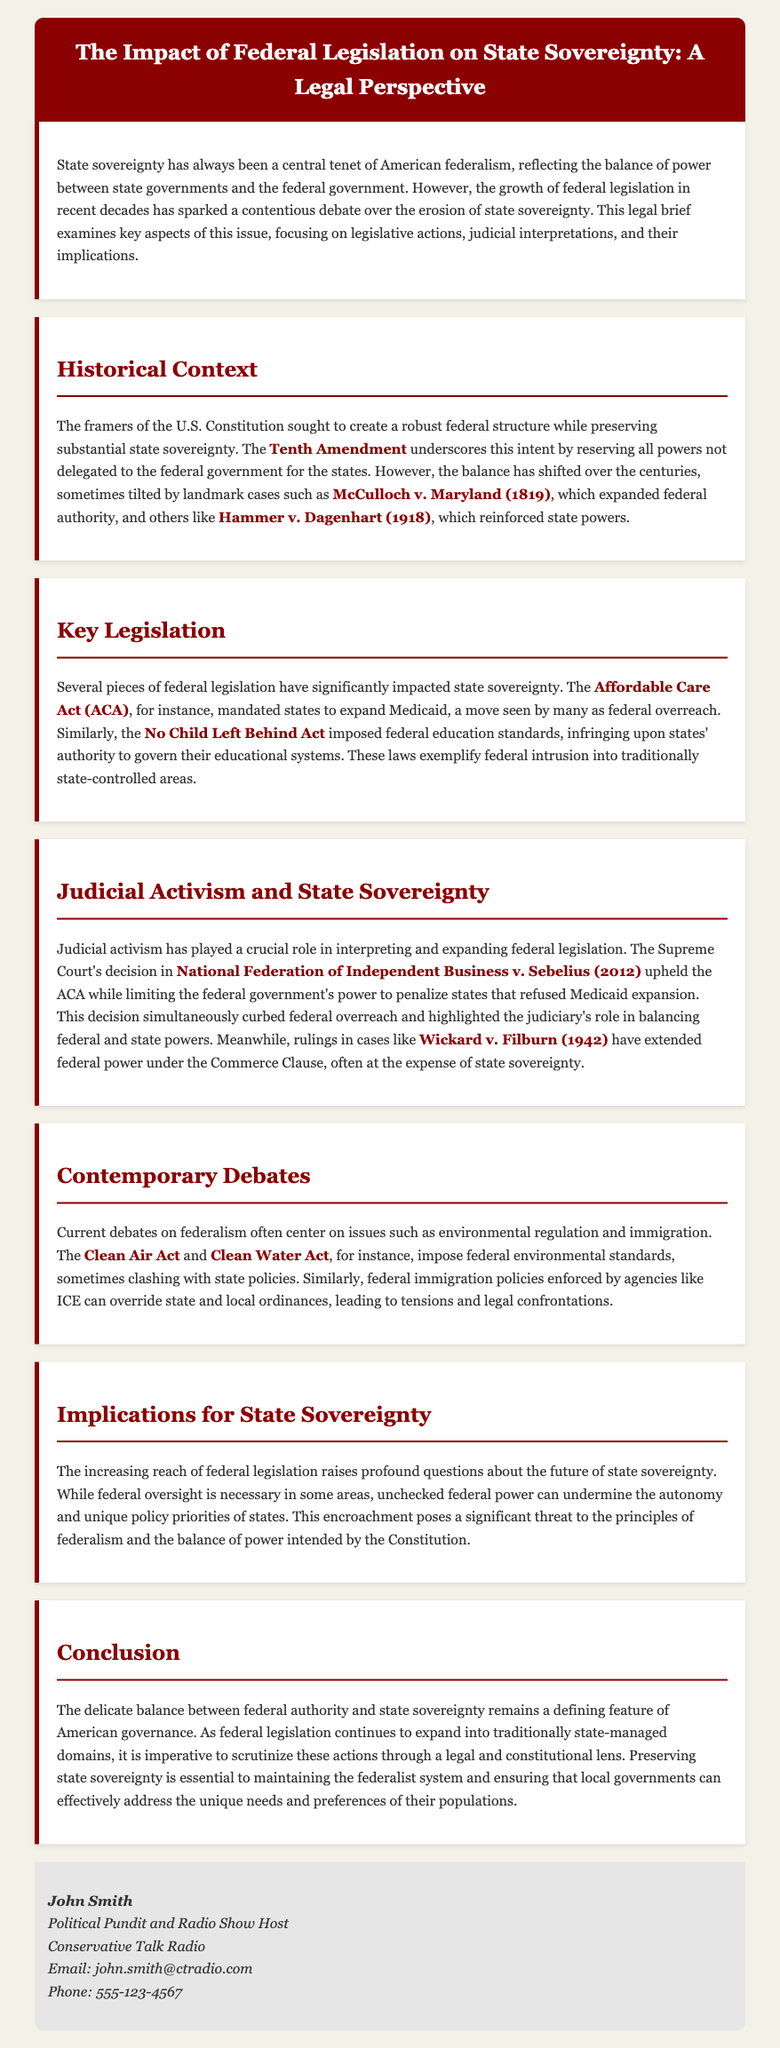What landmark case expanded federal authority? The document mentions McCulloch v. Maryland (1819) as a key case that expanded federal authority.
Answer: McCulloch v. Maryland (1819) Which amendment reserves powers for states? The Tenth Amendment is highlighted in the document as the amendment that reserves powers for states.
Answer: Tenth Amendment What act mandated states to expand Medicaid? The Affordable Care Act (ACA) is cited as the legislation that mandated states to expand Medicaid.
Answer: Affordable Care Act (ACA) What judicial decision limited federal power to penalize states? The National Federation of Independent Business v. Sebelius (2012) decision is mentioned for limiting federal power regarding Medicaid expansion.
Answer: National Federation of Independent Business v. Sebelius (2012) Which federal acts impose environmental standards? The Clean Air Act and the Clean Water Act are identified as having imposed federal environmental standards.
Answer: Clean Air Act and Clean Water Act What is a consequence of unchecked federal power? The document states that unchecked federal power can undermine the autonomy and unique policy priorities of states.
Answer: Undermine state autonomy Who authored the legal brief? The contact information at the end of the document provides the name of the author as John Smith.
Answer: John Smith What is the primary focus of the brief? The main focus of the brief is the impact of federal legislation on state sovereignty.
Answer: Federal legislation on state sovereignty In what year was Hammer v. Dagenhart decided? The document provides the year 1918 for the decision of the Hammer v. Dagenhart case.
Answer: 1918 